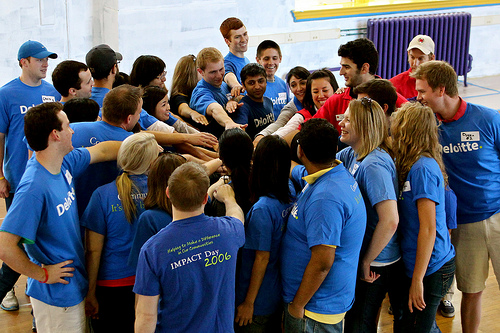<image>
Is the women to the left of the man? No. The women is not to the left of the man. From this viewpoint, they have a different horizontal relationship. 